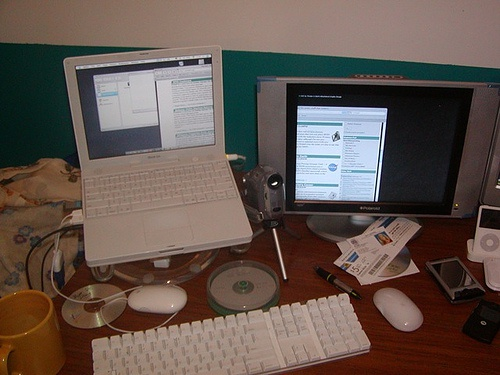Describe the objects in this image and their specific colors. I can see laptop in brown, gray, and darkgray tones, tv in brown, black, lavender, and gray tones, keyboard in brown, darkgray, and gray tones, keyboard in brown and gray tones, and cup in brown and maroon tones in this image. 